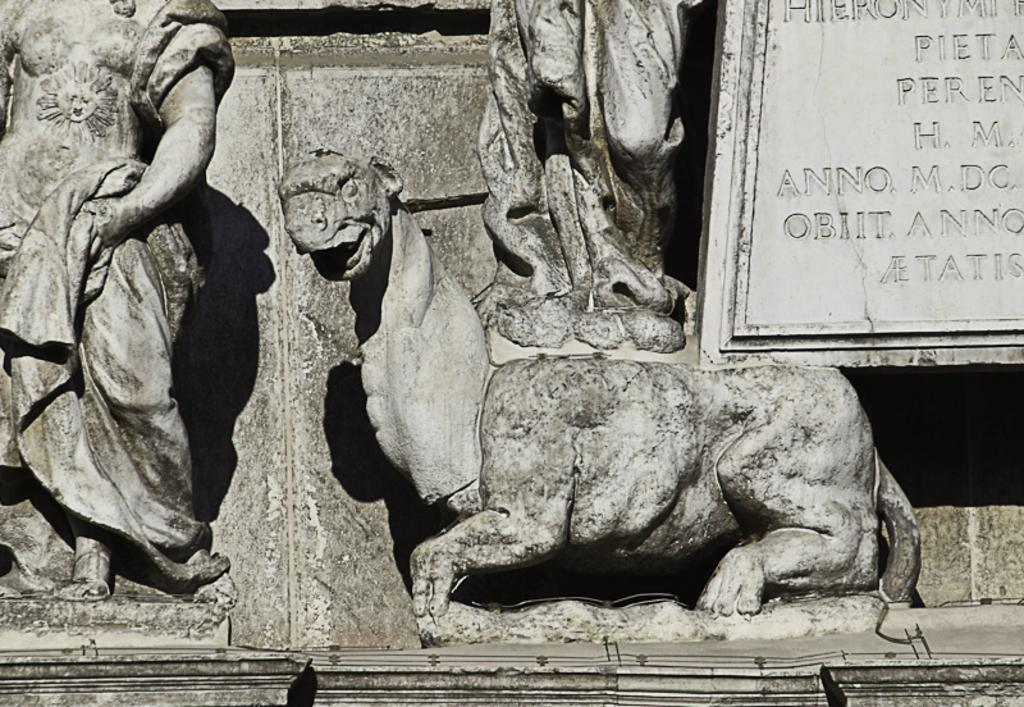What can be found towards the left side of the image? There are statues towards the left side of the image. What is located towards the right side of the image? There is a board towards the right side of the image. What is written or engraved on the board? There is text engraved on the board. Is there a room visible in the image? There is no mention of a room in the provided facts, so we cannot determine if a room is visible in the image. Can you describe the alley in the image? There is no mention of an alley in the provided facts, so we cannot describe an alley in the image. 